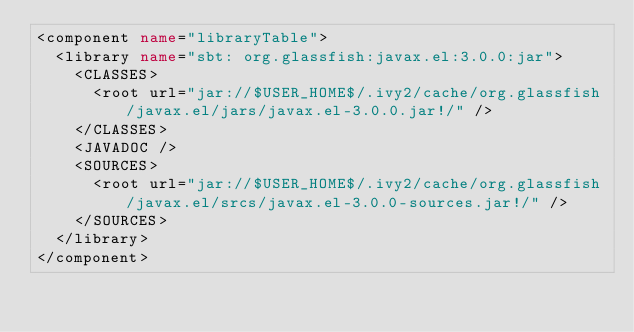<code> <loc_0><loc_0><loc_500><loc_500><_XML_><component name="libraryTable">
  <library name="sbt: org.glassfish:javax.el:3.0.0:jar">
    <CLASSES>
      <root url="jar://$USER_HOME$/.ivy2/cache/org.glassfish/javax.el/jars/javax.el-3.0.0.jar!/" />
    </CLASSES>
    <JAVADOC />
    <SOURCES>
      <root url="jar://$USER_HOME$/.ivy2/cache/org.glassfish/javax.el/srcs/javax.el-3.0.0-sources.jar!/" />
    </SOURCES>
  </library>
</component></code> 